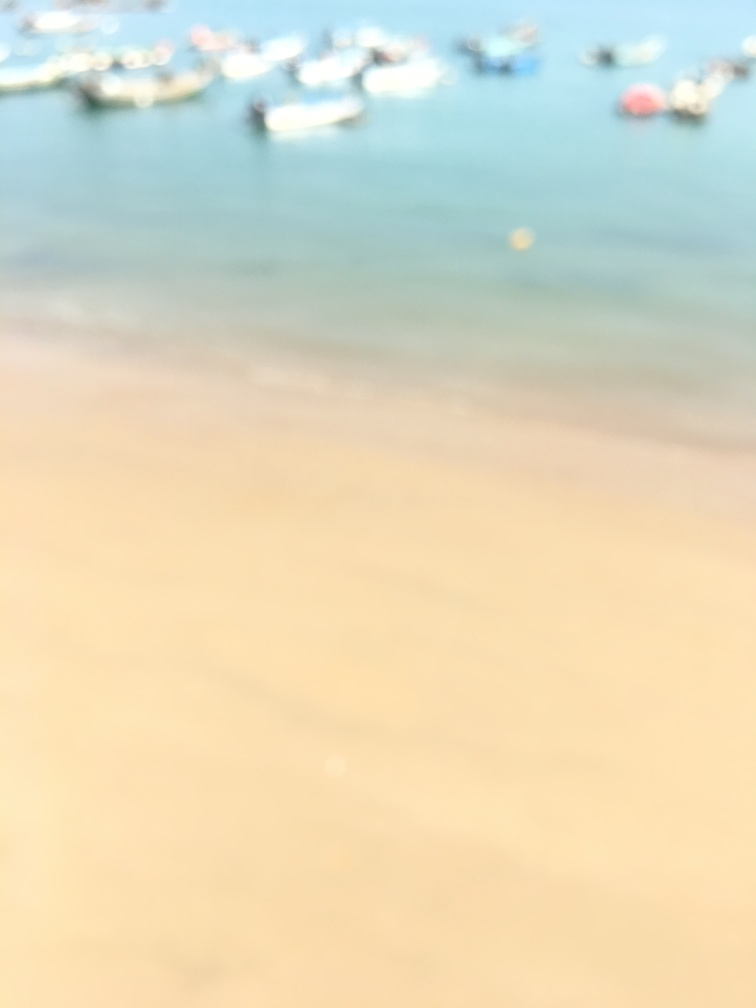How is the composition of the photo?
A. Chaotic and unorganized
B. Well-balanced
C. Symmetrical and perfect
D. Imbalanced and uneven
Answer with the option's letter from the given choices directly. It is impossible to accurately assess the composition of the photo as it is blurred and lacks visible details, making it challenging to determine its balance, symmetry, or organization. 